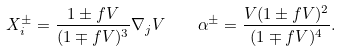Convert formula to latex. <formula><loc_0><loc_0><loc_500><loc_500>X _ { i } ^ { \pm } = \frac { 1 \pm f V } { ( 1 \mp f V ) ^ { 3 } } \nabla _ { j } V \quad \alpha ^ { \pm } = \frac { V ( 1 \pm f V ) ^ { 2 } } { ( 1 \mp f V ) ^ { 4 } } .</formula> 